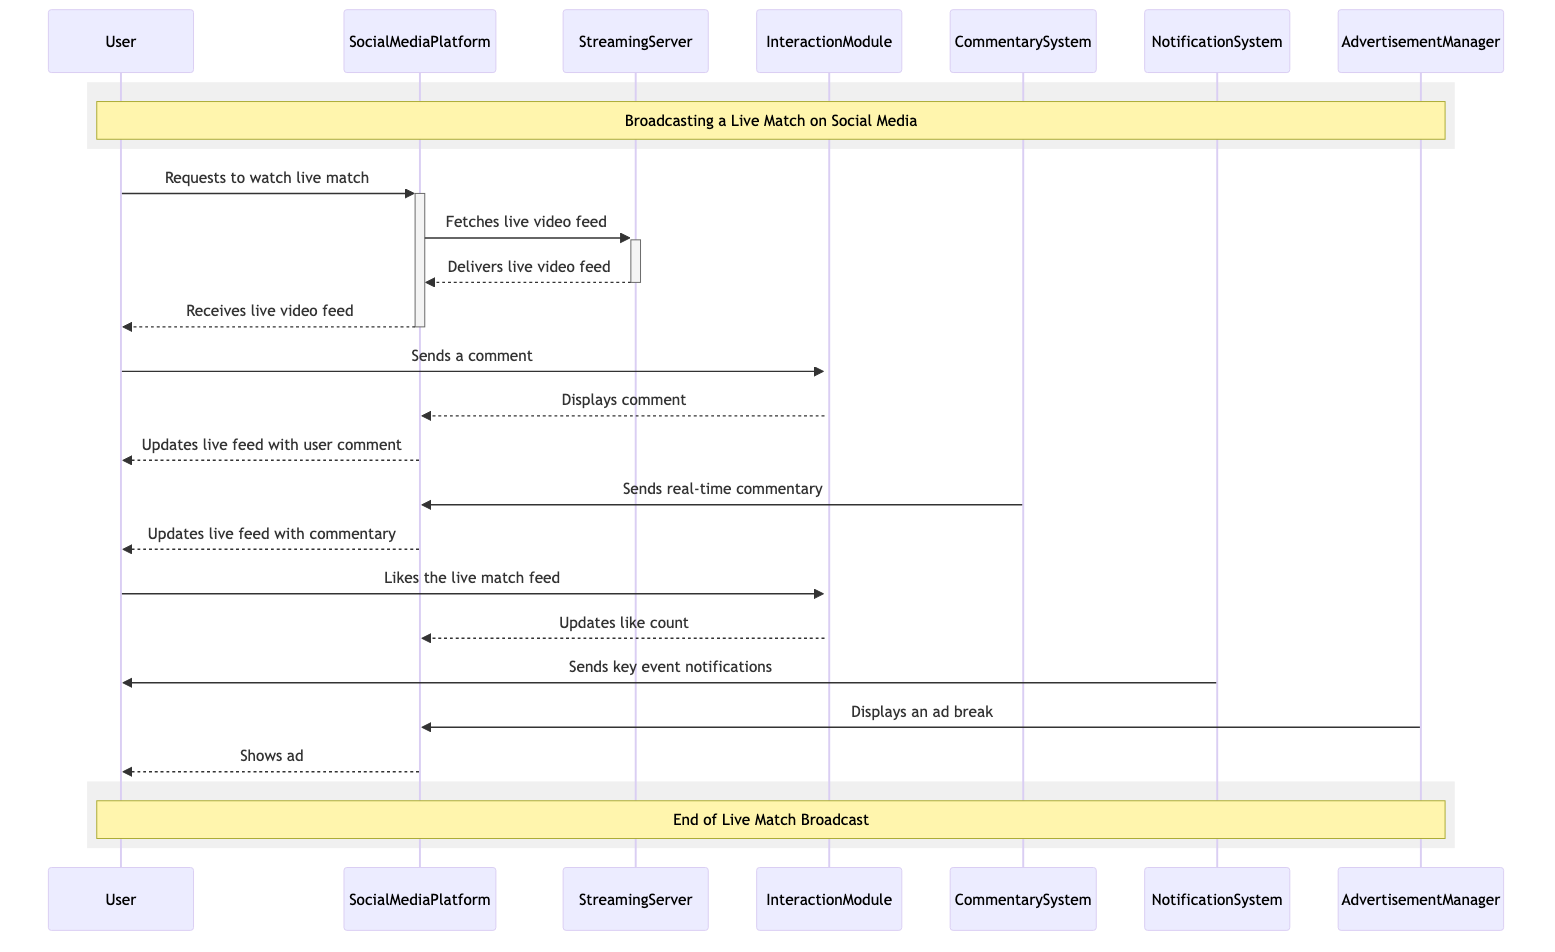What is the first action taken by the user? The diagram indicates that the first action is the user requesting to watch the live match by sending a message to the social media platform.
Answer: Requests to watch live match How many systems are involved in broadcasting the live match? The diagram shows a total of six systems involved in the process: User, Social Media Platform, Streaming Server, Interaction Module, Commentary System, Notification System, and Advertisement Manager.
Answer: Seven Who is responsible for delivering the live video feed? The Streaming Server is responsible for delivering the live video feed as indicated in the message flow from the Streaming Server to the Social Media Platform.
Answer: Streaming Server After sending a comment, what does the interaction module do next? Following the user's comment, the Interaction Module displays the comment on the Social Media Platform, which is the next action depicted in the diagram.
Answer: Displays comment What is the last action in the sequence diagram? The last action represented in the diagram is showing an advertisement to the user as part of the ad break displayed by the Social Media Platform.
Answer: Shows ad How does the Notification System interact with the user? The Notification System sends key event notifications to the user directly, as shown by the message flow from the Notification System to the User.
Answer: Sends key event notifications Which component provides real-time commentary? The Commentary System provides real-time commentary for the match, as captured in the step where it sends commentary to the Social Media Platform.
Answer: Commentary System What happens when the user likes the live match feed? When the user likes the live match feed, the Interaction Module updates the like count on the Social Media Platform, reflecting the interaction with the feed.
Answer: Updates like count 